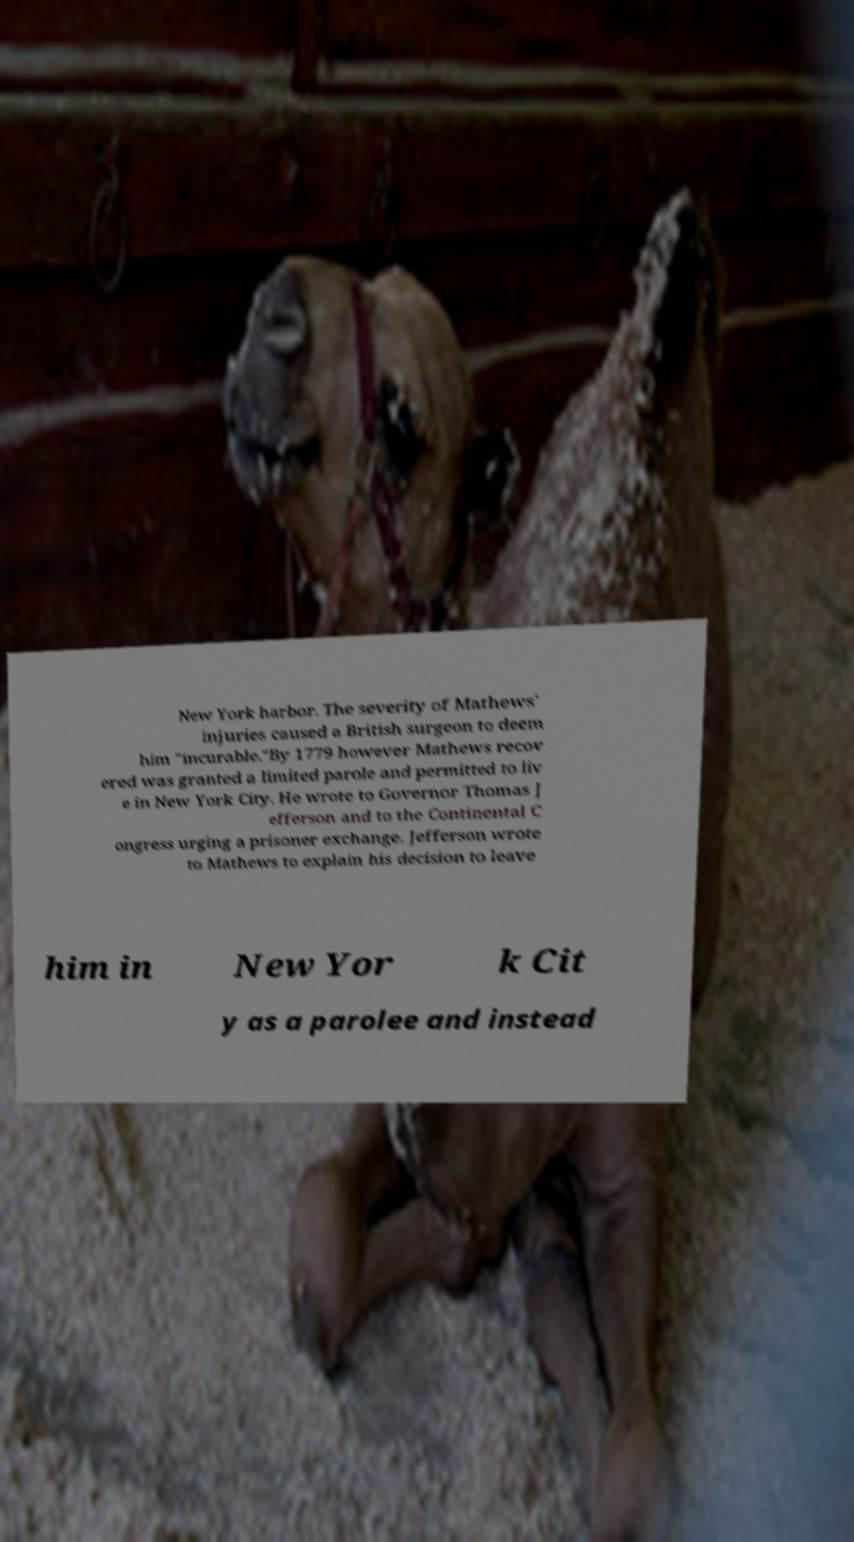Please read and relay the text visible in this image. What does it say? New York harbor. The severity of Mathews' injuries caused a British surgeon to deem him "incurable."By 1779 however Mathews recov ered was granted a limited parole and permitted to liv e in New York City. He wrote to Governor Thomas J efferson and to the Continental C ongress urging a prisoner exchange. Jefferson wrote to Mathews to explain his decision to leave him in New Yor k Cit y as a parolee and instead 